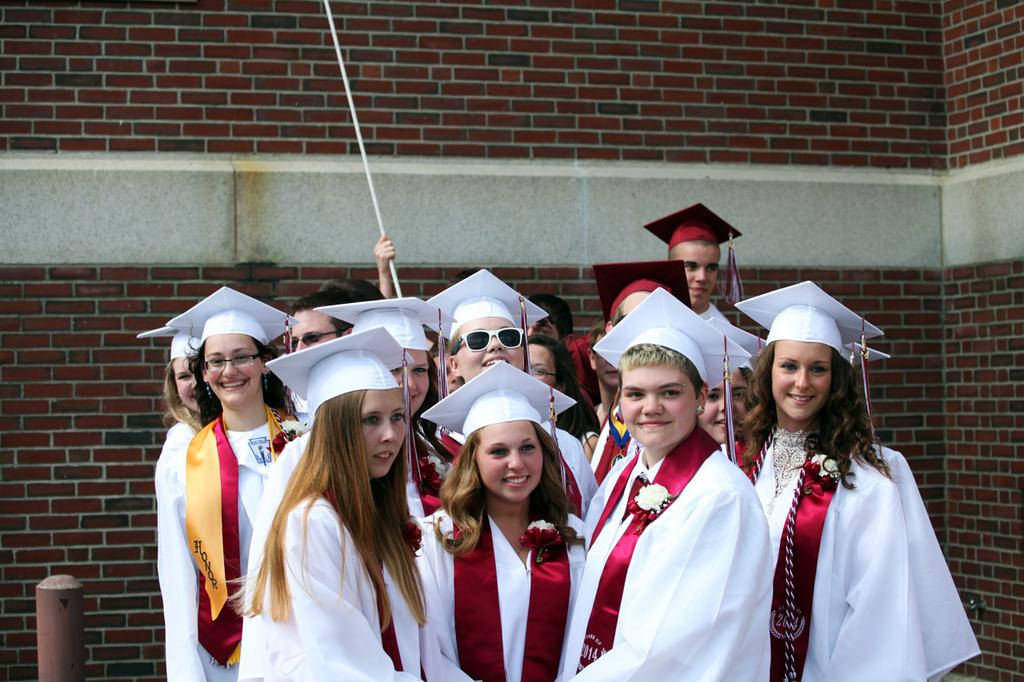What is the main subject of the image? The main subject of the image is a group of people. What are the people wearing in the image? The people are wearing graduation hats and graduation sashes. What can be seen in the background of the image? There is a wall in the background of the image. What type of wound can be seen on the graduation hat of the person in the image? There is no wound visible on any of the graduation hats in the image. 